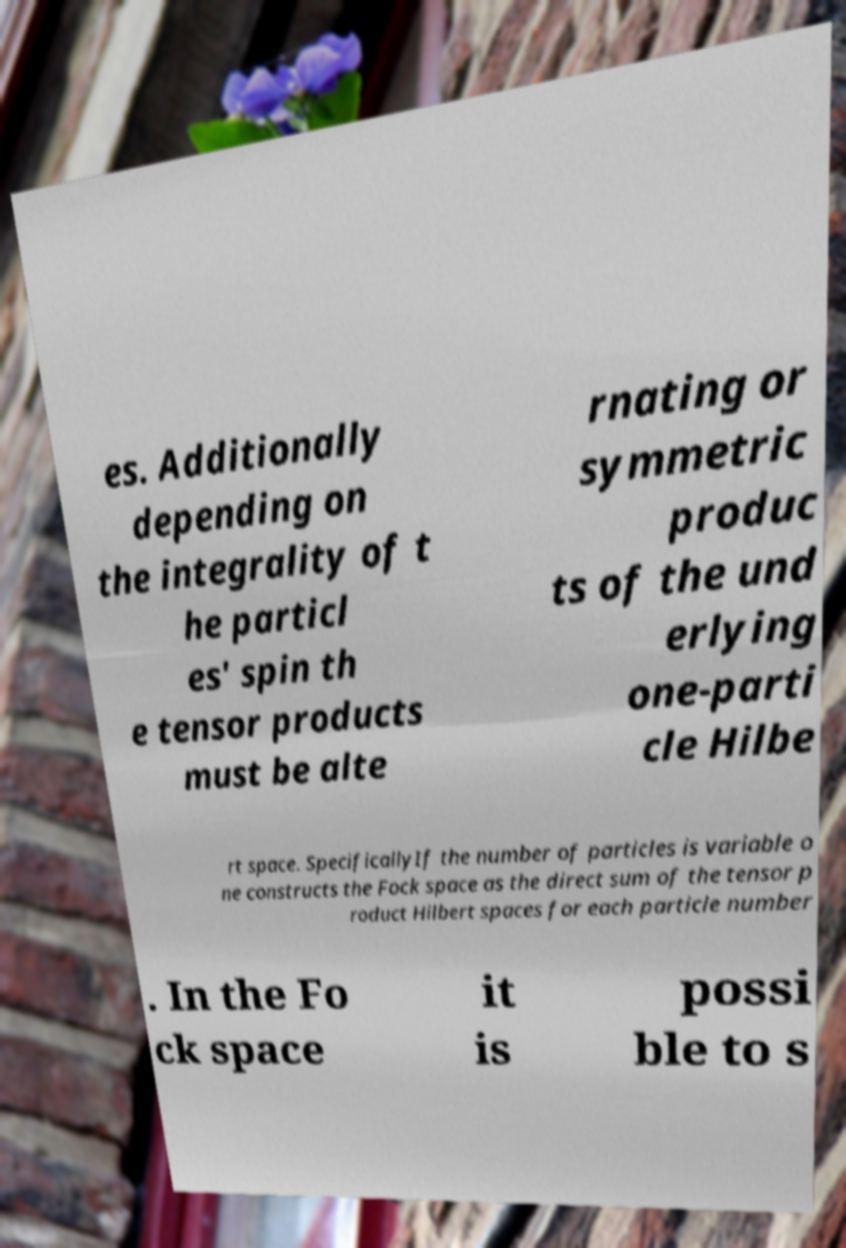What messages or text are displayed in this image? I need them in a readable, typed format. es. Additionally depending on the integrality of t he particl es' spin th e tensor products must be alte rnating or symmetric produc ts of the und erlying one-parti cle Hilbe rt space. SpecificallyIf the number of particles is variable o ne constructs the Fock space as the direct sum of the tensor p roduct Hilbert spaces for each particle number . In the Fo ck space it is possi ble to s 